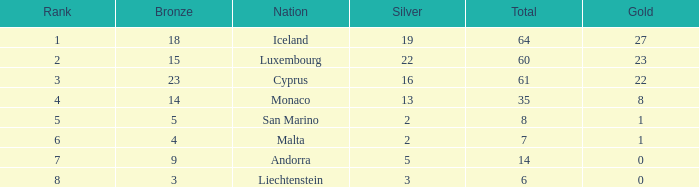How many bronzes for Iceland with over 2 silvers? 18.0. 